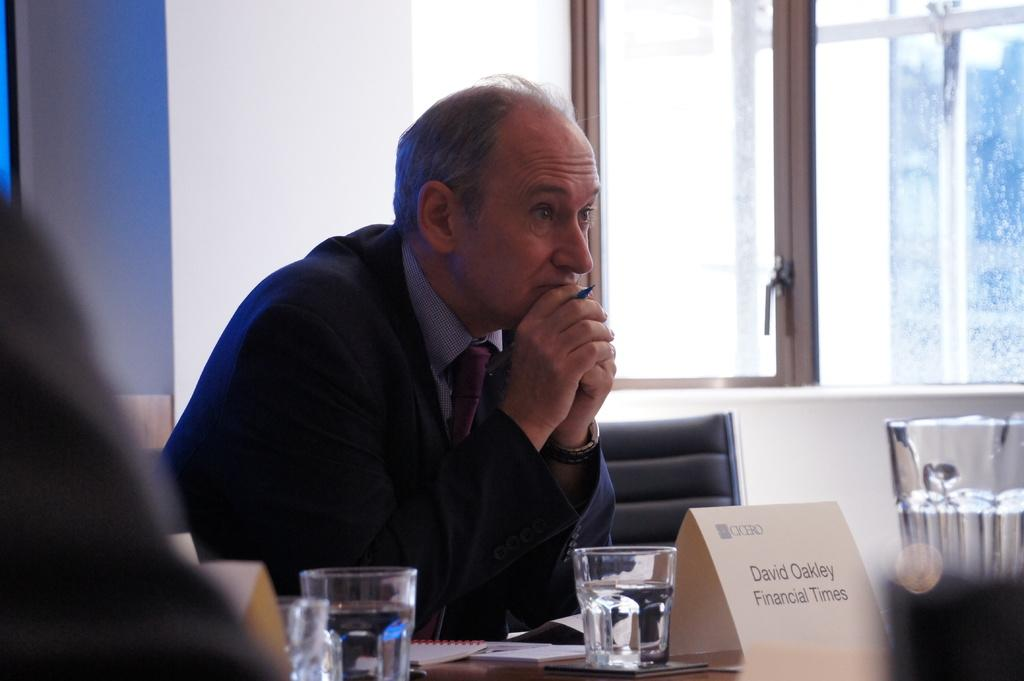<image>
Summarize the visual content of the image. A folded piece of paper that says David Oakley Financial Times is in front of a man at a table. 